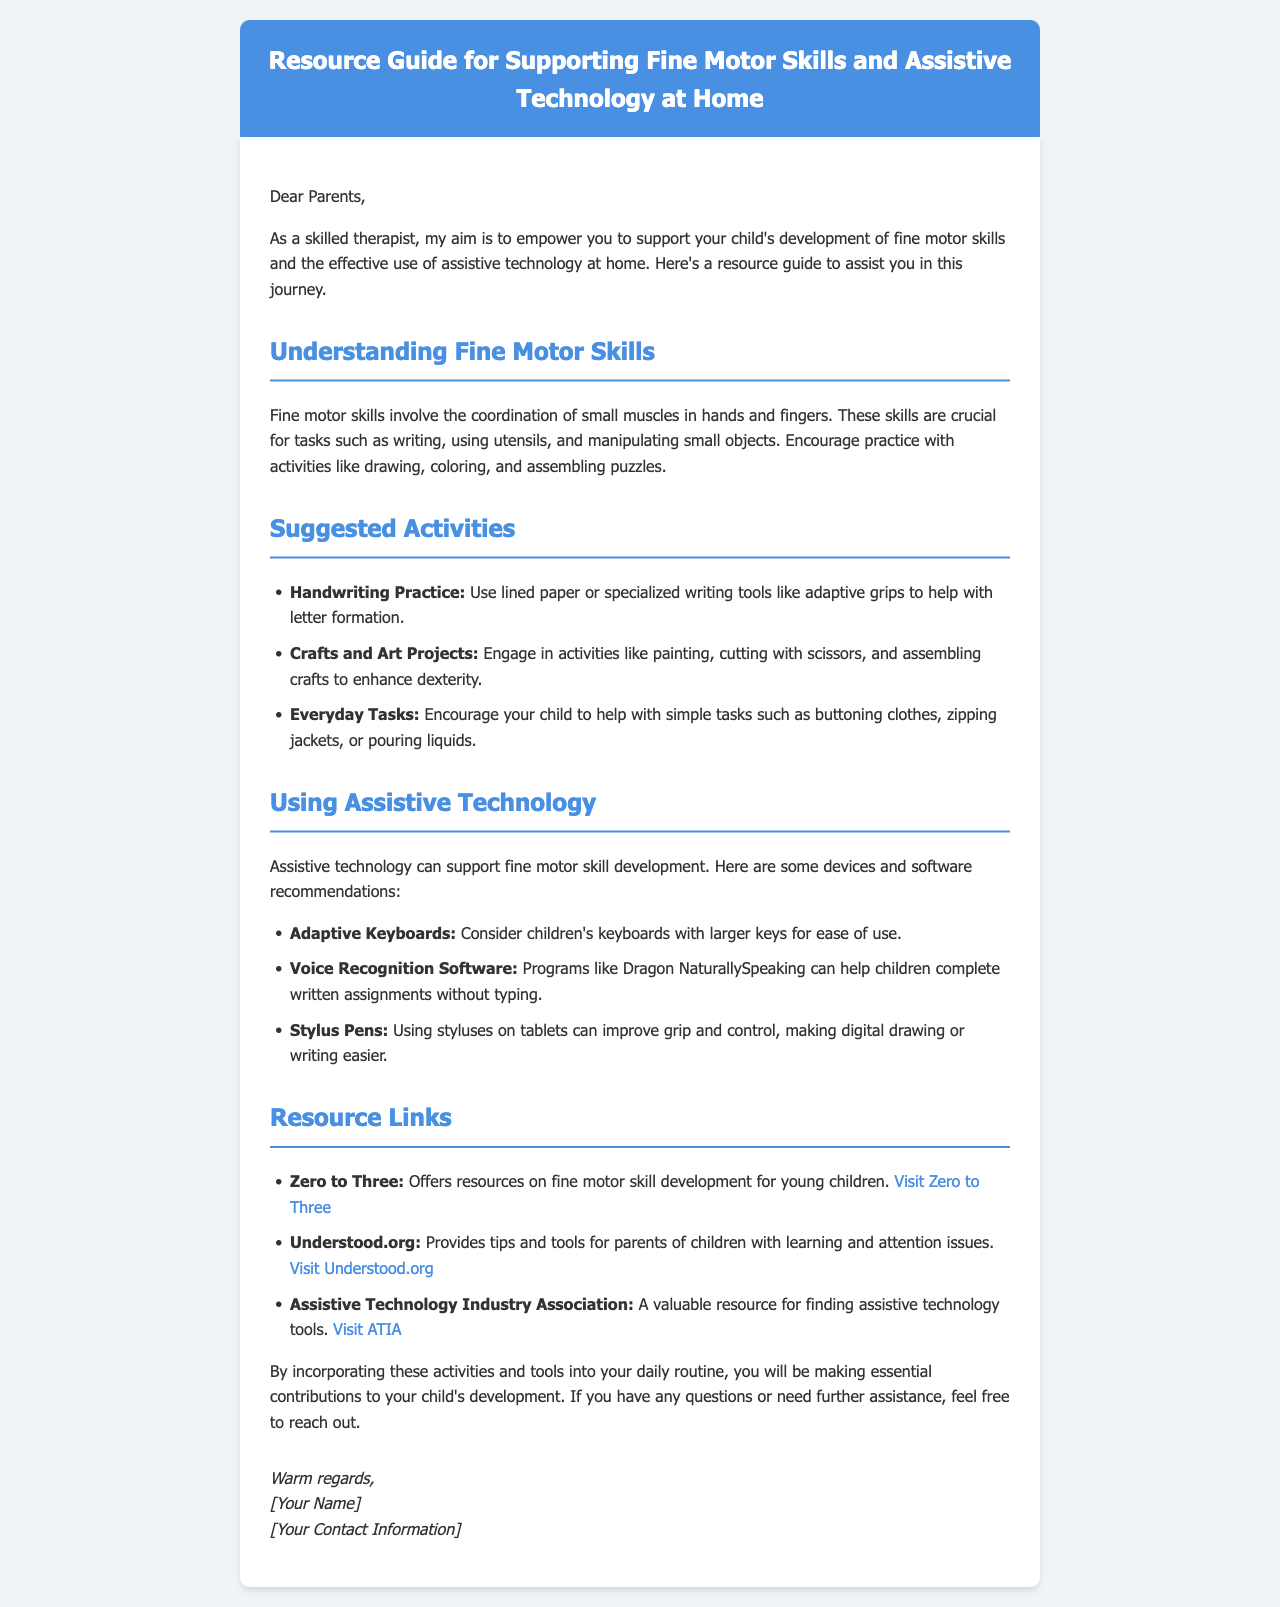What is the title of the document? The title is clearly stated in the header section of the document as "Resource Guide for Supporting Fine Motor Skills and Assistive Technology at Home."
Answer: Resource Guide for Supporting Fine Motor Skills and Assistive Technology at Home Who is the target audience of the document? The content is directly addressed to a specific group of people highlighted in the opening paragraph.
Answer: Parents What are fine motor skills? The definition is provided early in the document, describing what fine motor skills entail.
Answer: Coordination of small muscles in hands and fingers Name one suggested activity for fine motor skills development. The document lists several activities under the "Suggested Activities" section, of which one can be selected.
Answer: Handwriting Practice What type of assistive technology helps with typing? The document mentions specific tools that assist with typing tasks within the "Using Assistive Technology" section.
Answer: Adaptive Keyboards Which organization offers resources on fine motor skill development for young children? The "Resource Links" section refers to specific organizations that provide relevant resources.
Answer: Zero to Three What does voice recognition software help children do? The document explains the function of voice recognition software as it relates to completing tasks.
Answer: Complete written assignments How many resource links are provided in the document? The document includes a list of resource links that can be counted in the corresponding section.
Answer: Three What is the primary aim of the therapist mentioned in the document? The aim of the therapist is articulated clearly in the opening paragraph, serving as the document's purpose.
Answer: Empower parents to support their child's development 